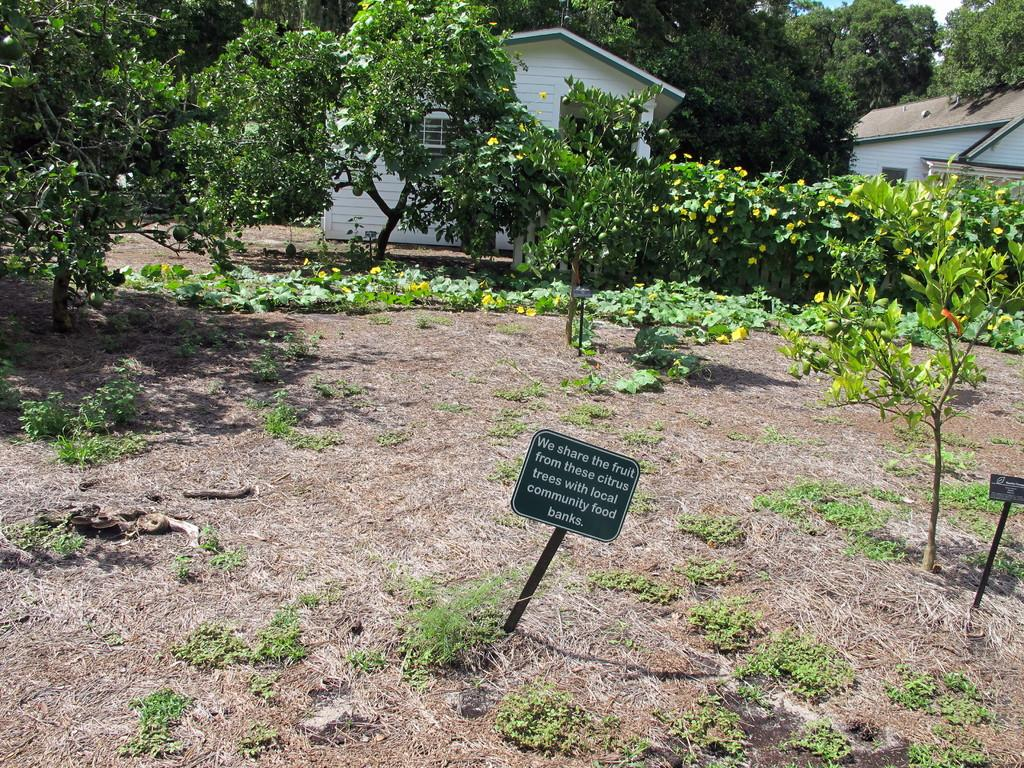What type of vegetation can be seen in the image? There are trees and plants in the image. What else is present in the image besides vegetation? There are boards with writing and houses in the image. What can be seen in the background of the image? The sky is visible in the background of the image. What caption is written on the ducks in the image? There are no ducks present in the image, so there is no caption written on any ducks. 